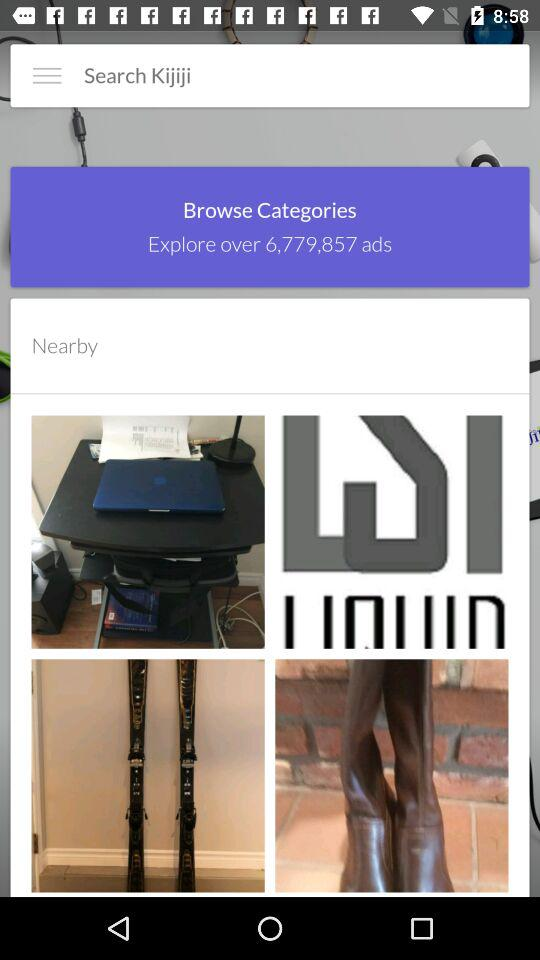What are the names of the ads listed?
When the provided information is insufficient, respond with <no answer>. <no answer> 